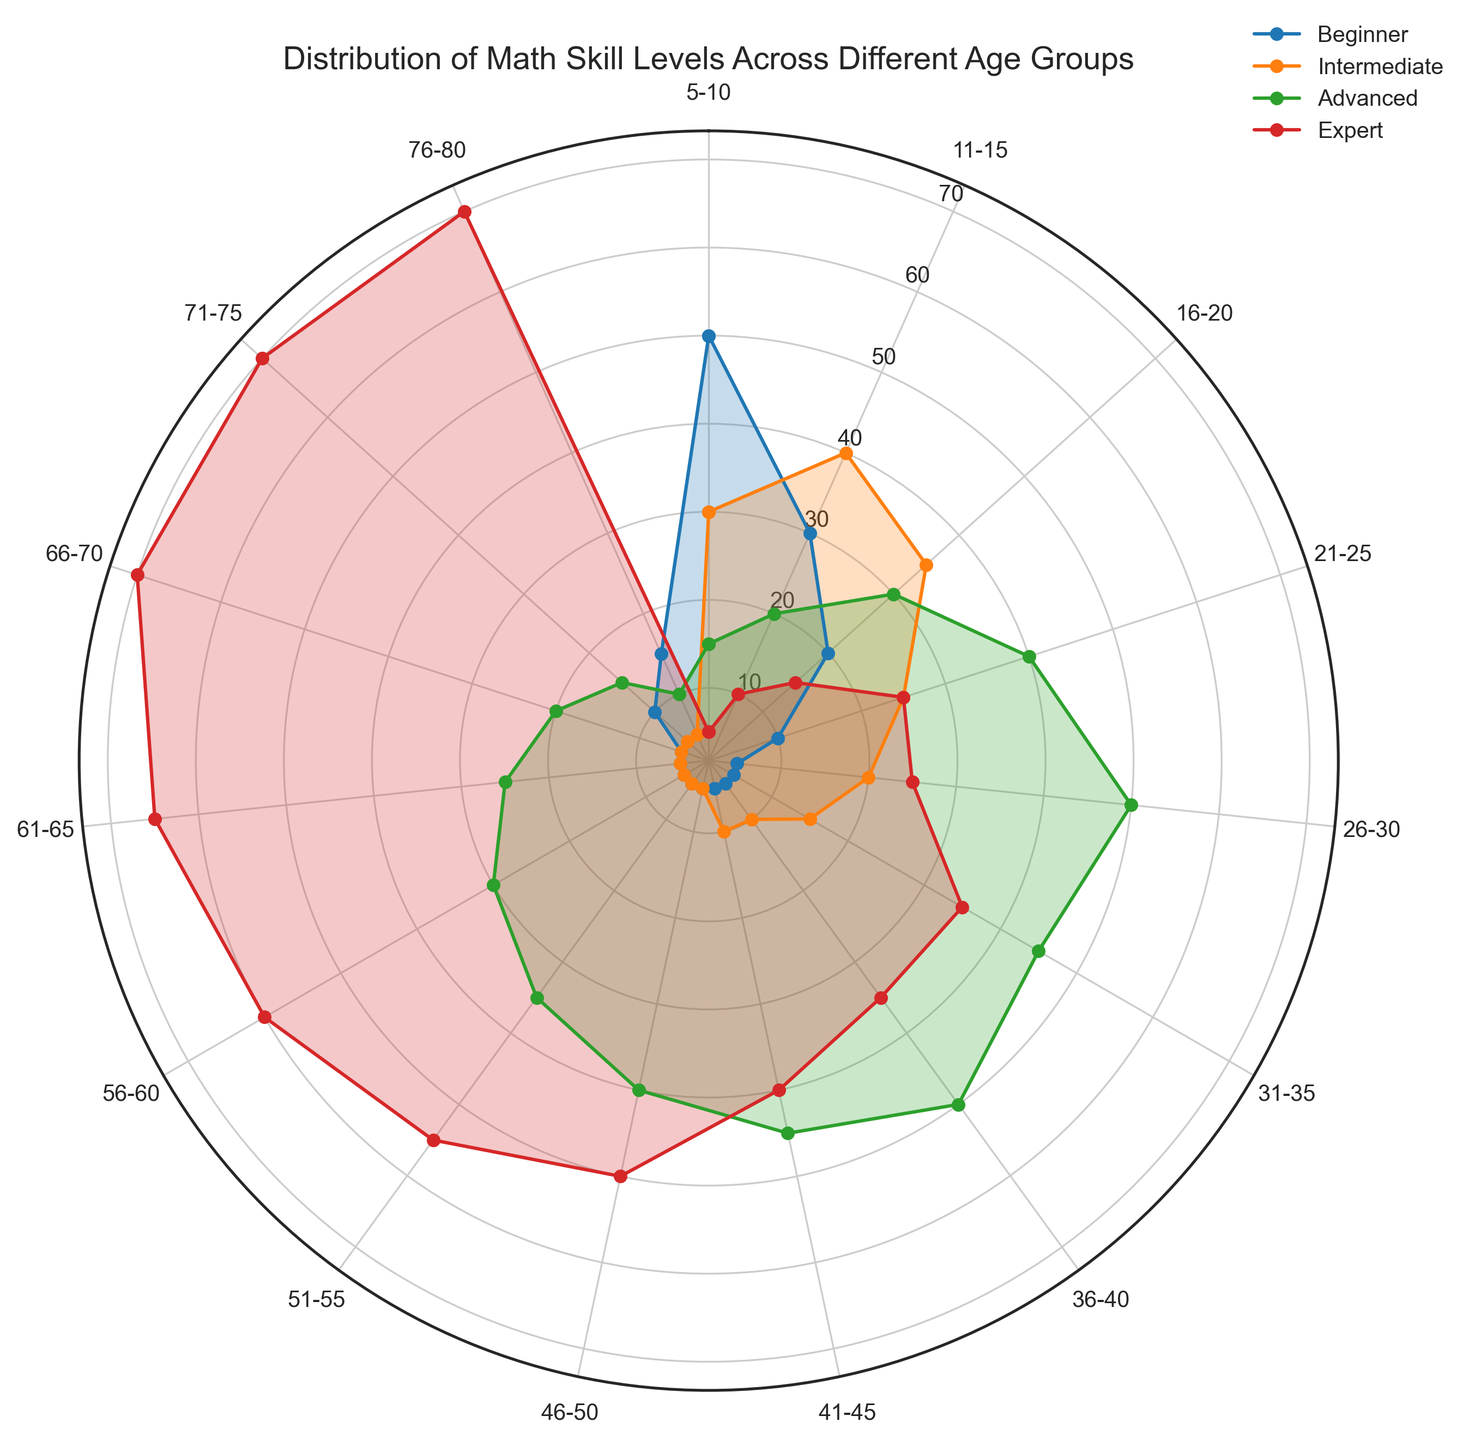What age group has the highest percentage of experts? Look at the outermost ring of the rose chart for the largest values. The outermost values represent the expert levels. The age group "66-70", "71-75", and "76-80" have the highest value at 70%.
Answer: 71-75 and 76-80 Which age group has more intermediate-level individuals, "11-15" or "16-20"? Look at the segments corresponding to the intermediate skill levels for these age groups. "11-15" has 40% and "16-20" has 35%.
Answer: 11-15 What is the sum of beginner percentages for age groups "31-35" and "36-40"? Check the values for beginners in these age groups and add them: "31-35" has 5% and "36-40" has 5%. 5 + 5 = 10
Answer: 10 Which skill level consistently increases with age, especially from "56-60" to "66-70"? Observe how each skill level changes as the age groups go from "56-60" to "66-70". Expert levels are increasing.
Answer: Expert In terms of advanced skill level, which group, "21-25" or "26-30", is depicted with a larger shaded area? Compare the segments representing advanced skill levels for these age groups. "26-30" has 50% while "21-25" has 40%.
Answer: 26-30 What is the difference in the percentage of experts between age groups "51-55" and "41-45"? Locate the expert values for "41-45" and "51-55". "41-45" has 40% and "51-55" has 55%. The difference is 55 - 40 = 15.
Answer: 15 How does the percentage of advanced-level individuals change from "26-30" to "31-35"? Compare the advanced-level values for these age groups. "26-30" has 50% while "31-35" has 45%.
Answer: Decreases What's the average expert percentage across age groups "66-70", "71-75", and "76-80"? Sum up the expert values and divide by the number of groups. Values are 70%, 70%, and 70%, so (70 + 70 + 70) / 3 = 70.
Answer: 70 Between "5-10" and "11-15", which group has a higher percentage of advanced individuals? Compare the segments representing advanced skill levels. "5-10" has 15% and "11-15" has 20%.
Answer: 11-15 Which age group has a higher visual prominence for expert level, "61-65" or "66-70"? Look at the longest segments for expert levels for these age groups. Both have the highest values, but visually "66-70" is slightly emphasized in the plot.
Answer: 66-70 